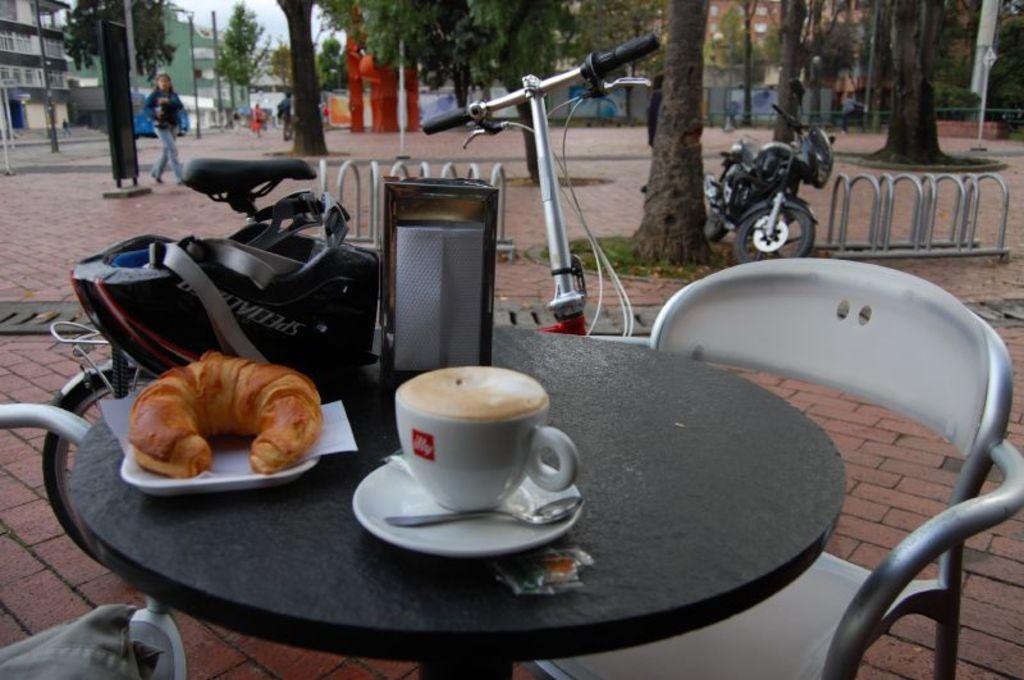Could you give a brief overview of what you see in this image? In this picture there is a table in a street where food items are kept on it. In the background we observe few trees,a bike and a lady. 